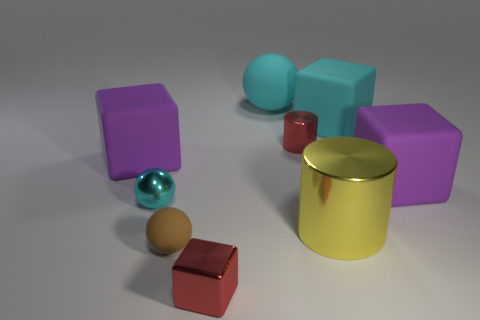Subtract all big cyan matte blocks. How many blocks are left? 3 Subtract all green spheres. How many purple cubes are left? 2 Subtract all red cubes. How many cubes are left? 3 Subtract 1 balls. How many balls are left? 2 Add 1 large objects. How many objects exist? 10 Subtract all green balls. Subtract all red cylinders. How many balls are left? 3 Subtract all cubes. How many objects are left? 5 Subtract all small red metallic blocks. Subtract all tiny red shiny blocks. How many objects are left? 7 Add 4 cyan objects. How many cyan objects are left? 7 Add 3 small balls. How many small balls exist? 5 